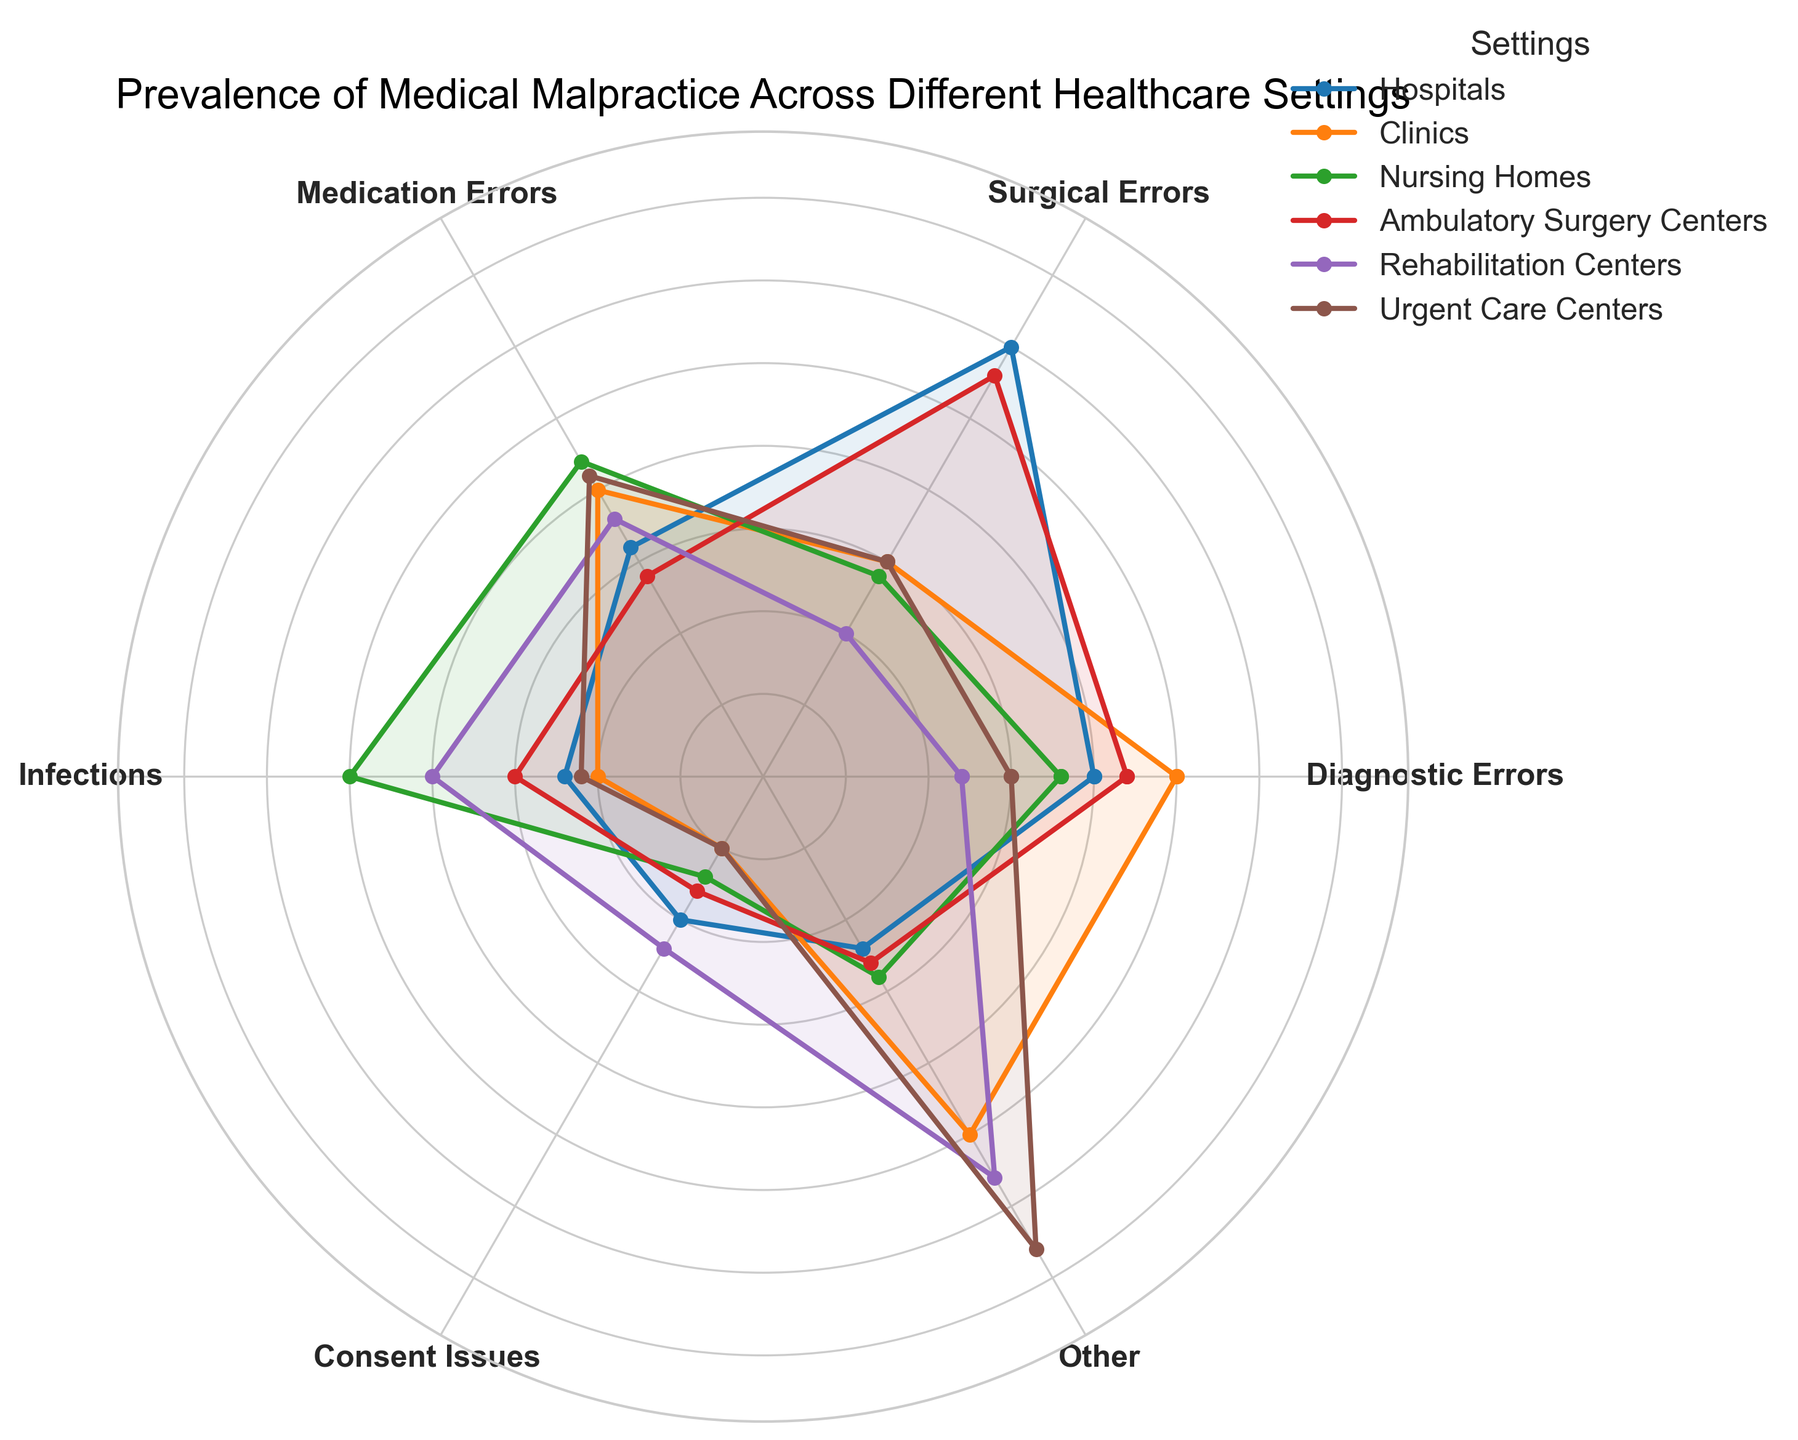Which healthcare setting has the highest prevalence of infections? Look at the 'Infections' category and compare the values of all settings. Nursing Homes have the highest value with 25.
Answer: Nursing Homes Which setting has more surgical errors, Hospitals or Ambulatory Surgery Centers? Compare the values in the 'Surgical Errors' category for Hospitals (30) and Ambulatory Surgery Centers (28). Hospitals have more surgical errors.
Answer: Hospitals What is the total prevalence of medication errors across Clinics and Urgent Care Centers? Add the values in the 'Medication Errors' category for Clinics (20) and Urgent Care Centers (21). 20 + 21 = 41.
Answer: 41 Is the prevalence of diagnostic errors at Hospitals greater than that of Nursing Homes? Compare the values in the 'Diagnostic Errors' category for Hospitals (20) and Nursing Homes (18). Hospitals have a greater value.
Answer: Yes Which category shows the most frequent occurrence at Rehabilitation Centers? Check the values for all categories at Rehabilitation Centers and find the highest value, which is in the 'Other' category with 28.
Answer: Other In which settings does the prevalence of consent issues match? Compare the values in the 'Consent Issues' category. Clinics and Urgent Care Centers both have a value of 5.
Answer: Clinics, Urgent Care Centers What is the average prevalence of surgical errors across all settings? Sum the values in the 'Surgical Errors' category (30 + 15 + 14 + 28 + 10 + 15) = 112. There are 6 settings, so 112/6 = 18.67.
Answer: 18.67 How does the prevalence of medication errors in Nursing Homes compare to that in Rehabilitation Centers? Compare the values in the 'Medication Errors' category for Nursing Homes (22) and Rehabilitation Centers (18). Nursing Homes have a higher value.
Answer: Nursing Homes have a higher value What is the combined prevalence of diagnostic errors and infections at Ambulatory Surgery Centers? Add the values in the 'Diagnostic Errors' (22) and 'Infections' (15) categories for Ambulatory Surgery Centers. 22 + 15 = 37.
Answer: 37 Which setting has the least total prevalence of errors if we sum all categories? Calculate the sum of all errors for each setting and find the smallest sum. Hospitals: 20+30+16+12+10+12=100, Clinics: 25+15+20+10+5+25=100, Nursing Homes: 18+14+22+25+7+14=100, Ambulatory Surgery Centers: 22+28+14+15+8+13=100, Rehabilitation Centers: 12+10+18+20+12+28=100, Urgent Care Centers: 15+15+21+11+5+33=100. They all have equal totals.
Answer: All settings are equal 